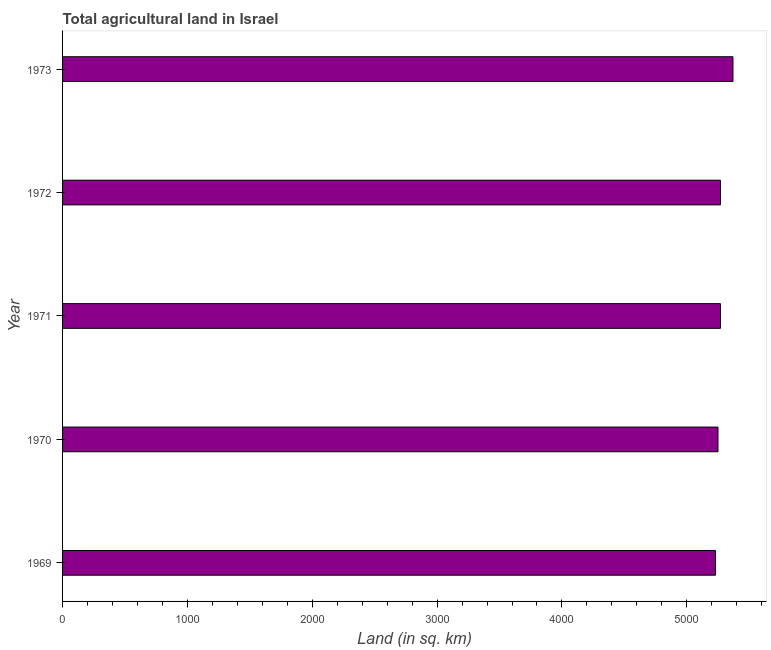Does the graph contain grids?
Offer a very short reply. No. What is the title of the graph?
Provide a short and direct response. Total agricultural land in Israel. What is the label or title of the X-axis?
Provide a succinct answer. Land (in sq. km). What is the label or title of the Y-axis?
Your answer should be compact. Year. What is the agricultural land in 1970?
Make the answer very short. 5250. Across all years, what is the maximum agricultural land?
Give a very brief answer. 5370. Across all years, what is the minimum agricultural land?
Keep it short and to the point. 5230. In which year was the agricultural land minimum?
Your response must be concise. 1969. What is the sum of the agricultural land?
Ensure brevity in your answer.  2.64e+04. What is the difference between the agricultural land in 1971 and 1973?
Your response must be concise. -100. What is the average agricultural land per year?
Give a very brief answer. 5278. What is the median agricultural land?
Provide a succinct answer. 5270. In how many years, is the agricultural land greater than 1800 sq. km?
Provide a succinct answer. 5. Is the agricultural land in 1969 less than that in 1970?
Offer a very short reply. Yes. Is the difference between the agricultural land in 1970 and 1972 greater than the difference between any two years?
Give a very brief answer. No. Is the sum of the agricultural land in 1969 and 1972 greater than the maximum agricultural land across all years?
Provide a succinct answer. Yes. What is the difference between the highest and the lowest agricultural land?
Your response must be concise. 140. How many bars are there?
Provide a short and direct response. 5. Are all the bars in the graph horizontal?
Give a very brief answer. Yes. What is the difference between two consecutive major ticks on the X-axis?
Provide a succinct answer. 1000. Are the values on the major ticks of X-axis written in scientific E-notation?
Your answer should be compact. No. What is the Land (in sq. km) in 1969?
Provide a succinct answer. 5230. What is the Land (in sq. km) in 1970?
Ensure brevity in your answer.  5250. What is the Land (in sq. km) of 1971?
Provide a short and direct response. 5270. What is the Land (in sq. km) in 1972?
Offer a terse response. 5270. What is the Land (in sq. km) of 1973?
Keep it short and to the point. 5370. What is the difference between the Land (in sq. km) in 1969 and 1971?
Your answer should be compact. -40. What is the difference between the Land (in sq. km) in 1969 and 1972?
Make the answer very short. -40. What is the difference between the Land (in sq. km) in 1969 and 1973?
Provide a succinct answer. -140. What is the difference between the Land (in sq. km) in 1970 and 1973?
Your answer should be compact. -120. What is the difference between the Land (in sq. km) in 1971 and 1973?
Ensure brevity in your answer.  -100. What is the difference between the Land (in sq. km) in 1972 and 1973?
Provide a short and direct response. -100. What is the ratio of the Land (in sq. km) in 1969 to that in 1973?
Provide a short and direct response. 0.97. What is the ratio of the Land (in sq. km) in 1970 to that in 1971?
Your answer should be compact. 1. What is the ratio of the Land (in sq. km) in 1970 to that in 1972?
Your response must be concise. 1. What is the ratio of the Land (in sq. km) in 1970 to that in 1973?
Make the answer very short. 0.98. What is the ratio of the Land (in sq. km) in 1971 to that in 1972?
Offer a very short reply. 1. What is the ratio of the Land (in sq. km) in 1972 to that in 1973?
Your answer should be compact. 0.98. 